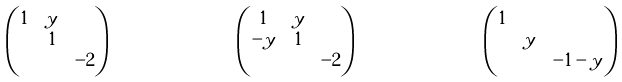<formula> <loc_0><loc_0><loc_500><loc_500>& \begin{pmatrix} 1 & y & \\ & 1 & \\ & & - 2 \end{pmatrix} & & \begin{pmatrix} 1 & y & \\ - y & 1 & \\ & & - 2 \end{pmatrix} & & \begin{pmatrix} 1 & & \\ & y & \\ & & - 1 - y \end{pmatrix}</formula> 